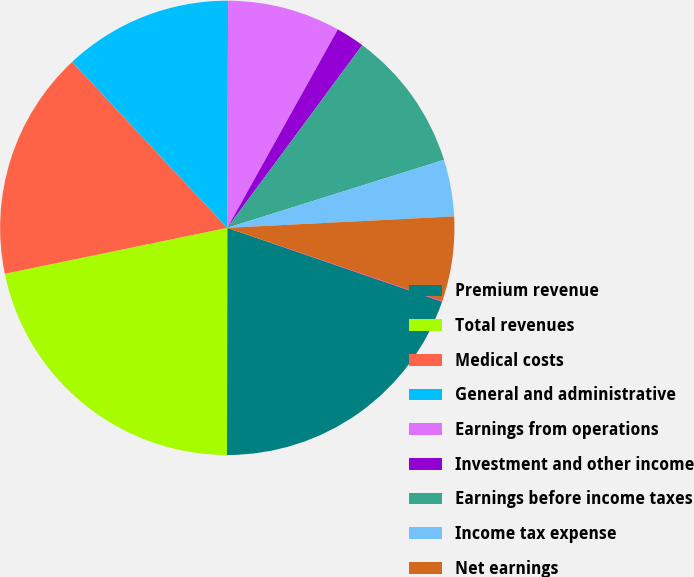Convert chart. <chart><loc_0><loc_0><loc_500><loc_500><pie_chart><fcel>Premium revenue<fcel>Total revenues<fcel>Medical costs<fcel>General and administrative<fcel>Earnings from operations<fcel>Investment and other income<fcel>Earnings before income taxes<fcel>Income tax expense<fcel>Net earnings<fcel>Diluted earnings per common<nl><fcel>19.75%<fcel>21.74%<fcel>16.28%<fcel>12.02%<fcel>8.03%<fcel>2.04%<fcel>10.03%<fcel>4.04%<fcel>6.03%<fcel>0.04%<nl></chart> 